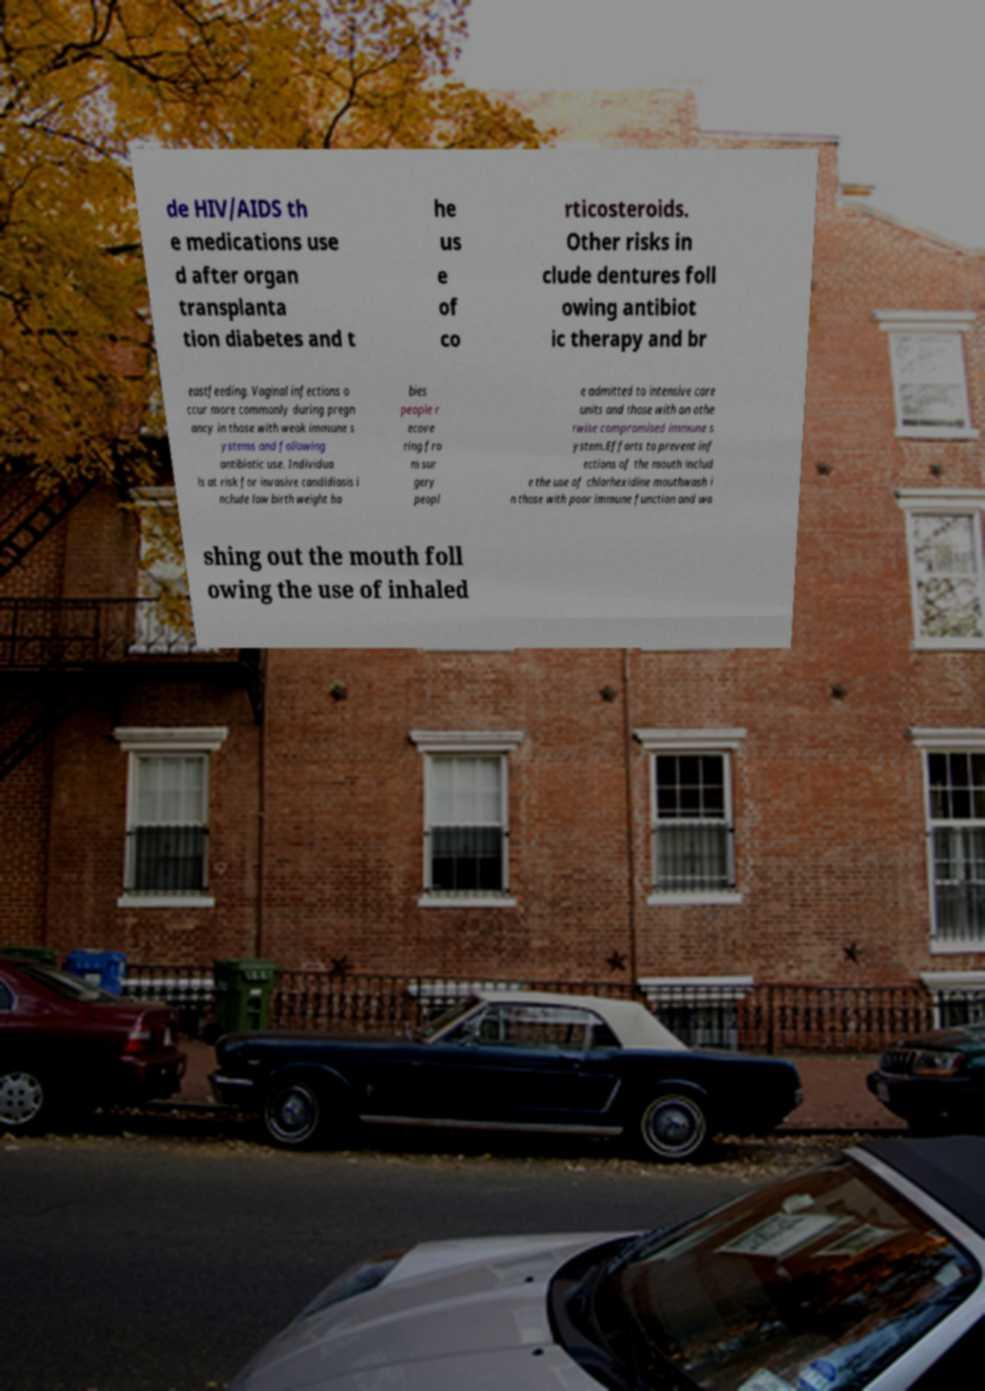Can you accurately transcribe the text from the provided image for me? de HIV/AIDS th e medications use d after organ transplanta tion diabetes and t he us e of co rticosteroids. Other risks in clude dentures foll owing antibiot ic therapy and br eastfeeding. Vaginal infections o ccur more commonly during pregn ancy in those with weak immune s ystems and following antibiotic use. Individua ls at risk for invasive candidiasis i nclude low birth weight ba bies people r ecove ring fro m sur gery peopl e admitted to intensive care units and those with an othe rwise compromised immune s ystem.Efforts to prevent inf ections of the mouth includ e the use of chlorhexidine mouthwash i n those with poor immune function and wa shing out the mouth foll owing the use of inhaled 